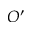<formula> <loc_0><loc_0><loc_500><loc_500>O ^ { \prime }</formula> 